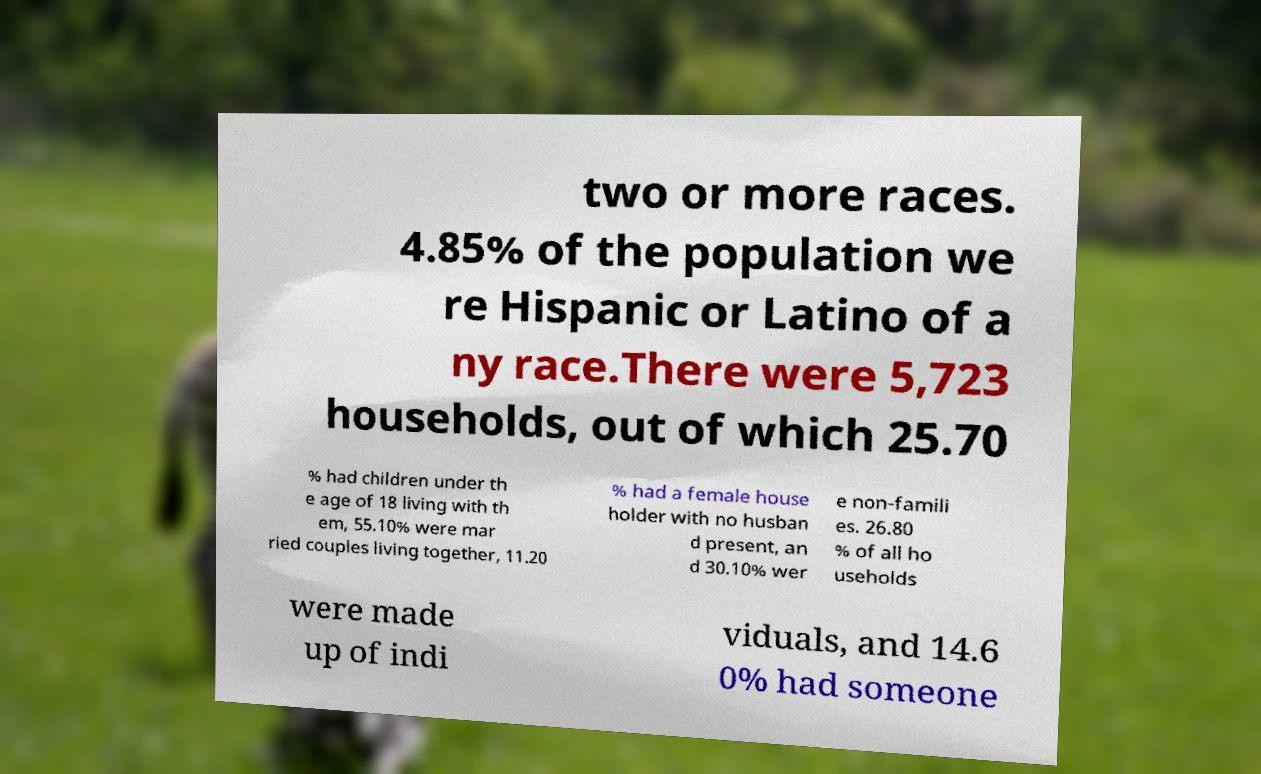Can you accurately transcribe the text from the provided image for me? two or more races. 4.85% of the population we re Hispanic or Latino of a ny race.There were 5,723 households, out of which 25.70 % had children under th e age of 18 living with th em, 55.10% were mar ried couples living together, 11.20 % had a female house holder with no husban d present, an d 30.10% wer e non-famili es. 26.80 % of all ho useholds were made up of indi viduals, and 14.6 0% had someone 